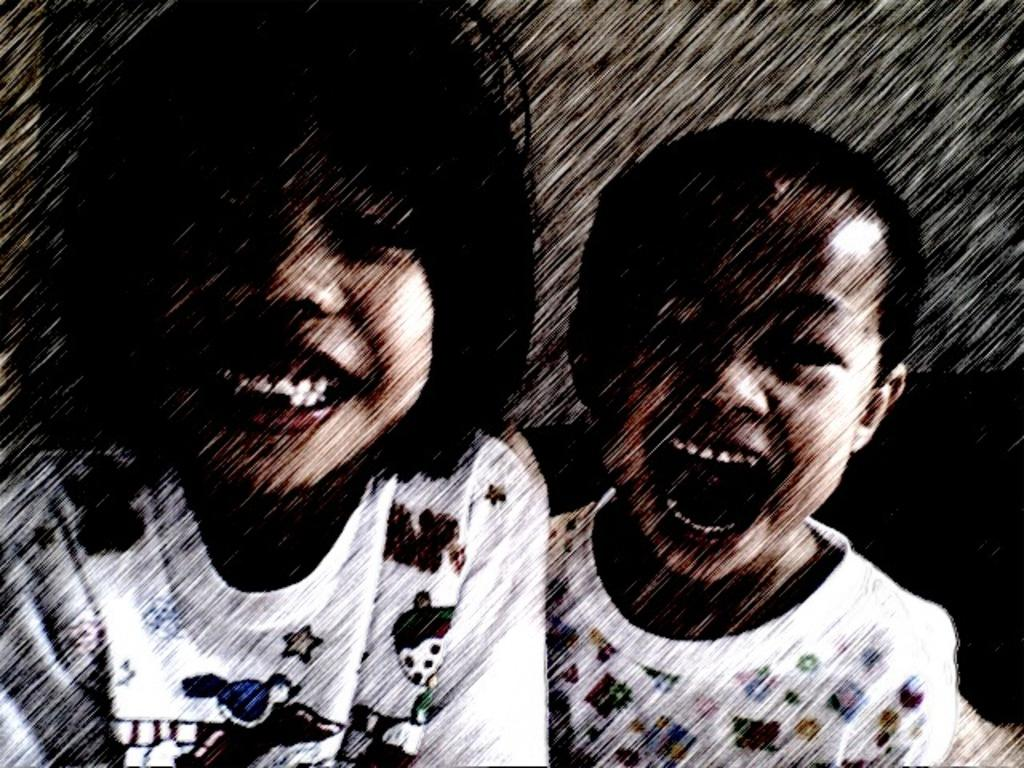How many persons are in the image? There are persons in the image, but the exact number is not specified. What is the facial expression of the persons in the image? The persons in the image are smiling. What type of oil can be seen dripping from the persons' faces in the image? There is no oil present in the image, and therefore no such dripping can be observed. What type of land is visible in the background of the image? The provided facts do not mention any land or background, so it cannot be determined from the image. 